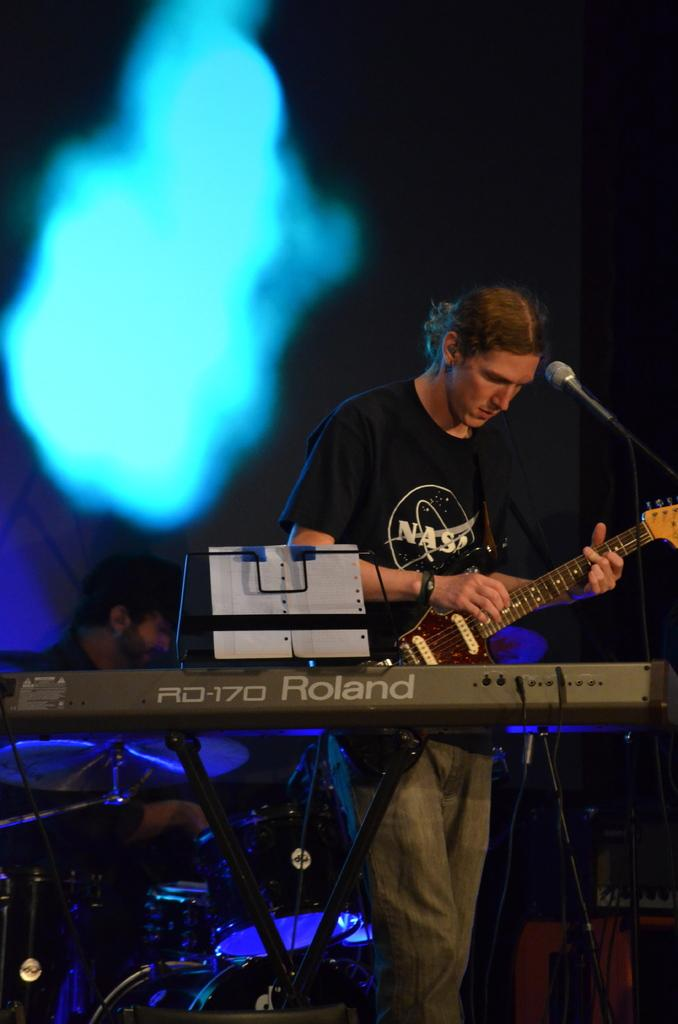Who is the main subject in the image? There is a man in the image. What is the man holding in the image? The man is holding a guitar. What is the man doing with the guitar? The man is playing the guitar. What can be seen in front of the man? There is a microphone in front of the man. What other musical activity is happening in the background? There is a person playing drums in the background. How many knots are tied in the guitar strings in the image? There are no knots visible in the guitar strings in the image. What type of fruit is being used as a prop in the image? There is no fruit present in the image. 